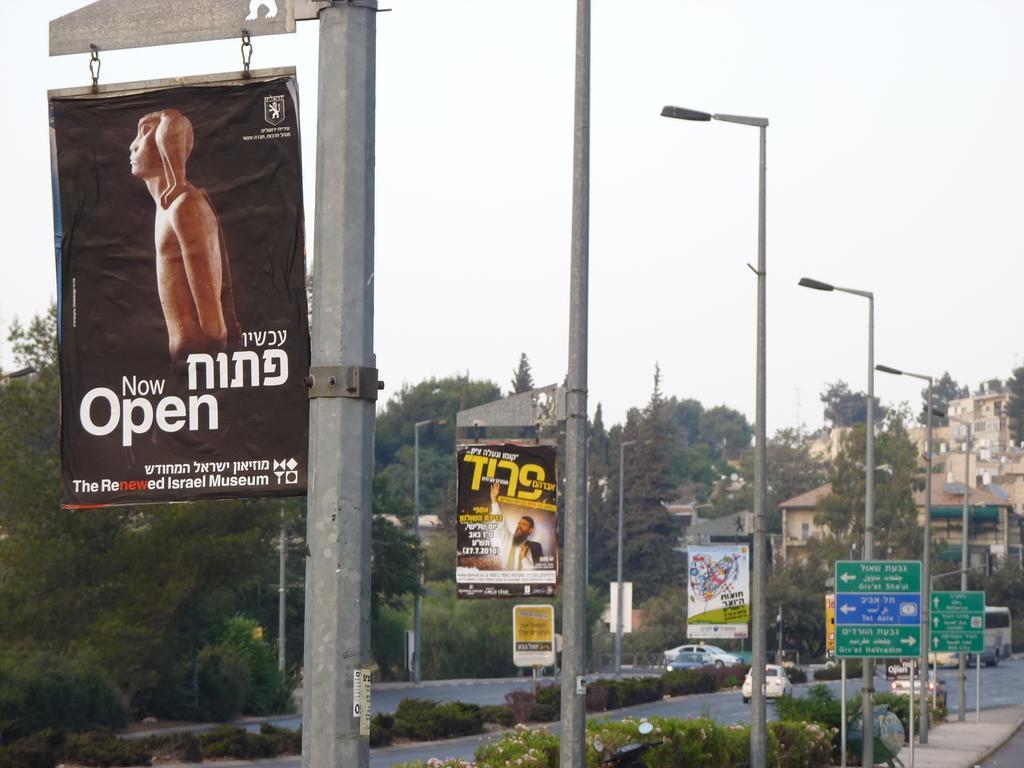Describe this image in one or two sentences. In this picture we can see there are poles with banners, lights and directional boards. On the left side of the poles there are plants and some vehicles on the road. Behind the vehicles there are trees, buildings and the sky. 